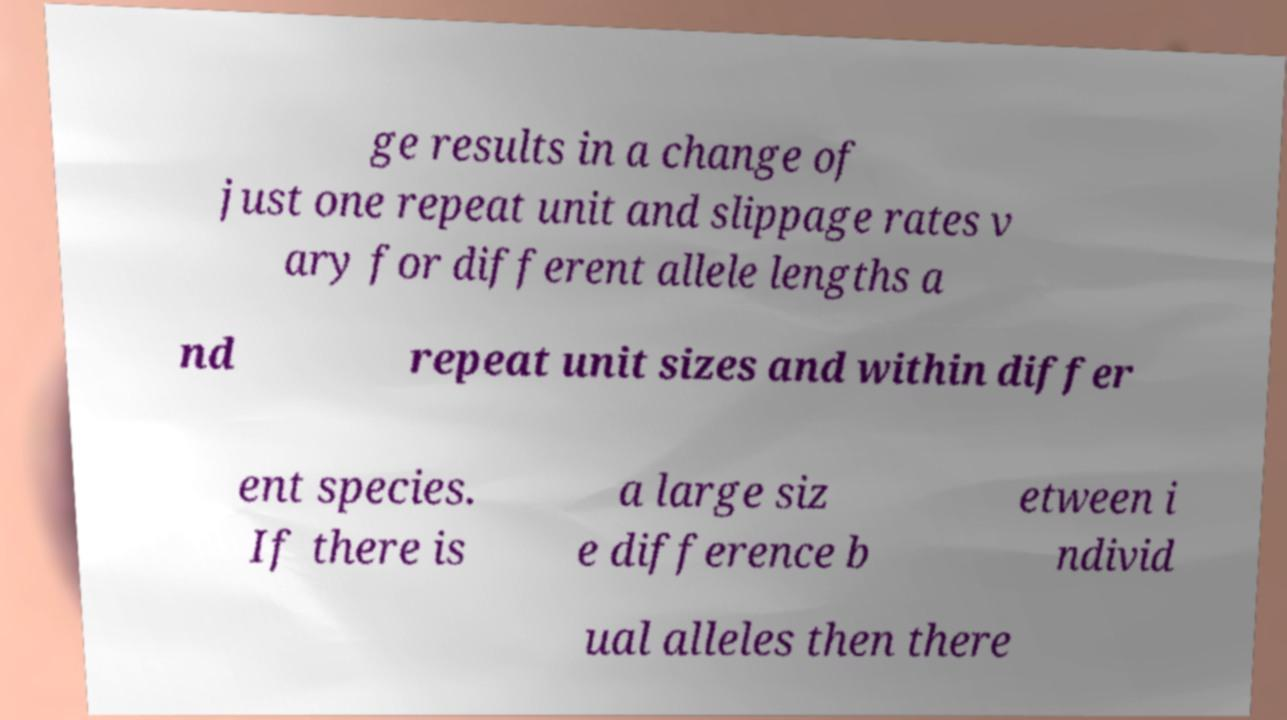I need the written content from this picture converted into text. Can you do that? ge results in a change of just one repeat unit and slippage rates v ary for different allele lengths a nd repeat unit sizes and within differ ent species. If there is a large siz e difference b etween i ndivid ual alleles then there 